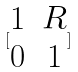Convert formula to latex. <formula><loc_0><loc_0><loc_500><loc_500>[ \begin{matrix} 1 & R \\ 0 & 1 \end{matrix} ]</formula> 